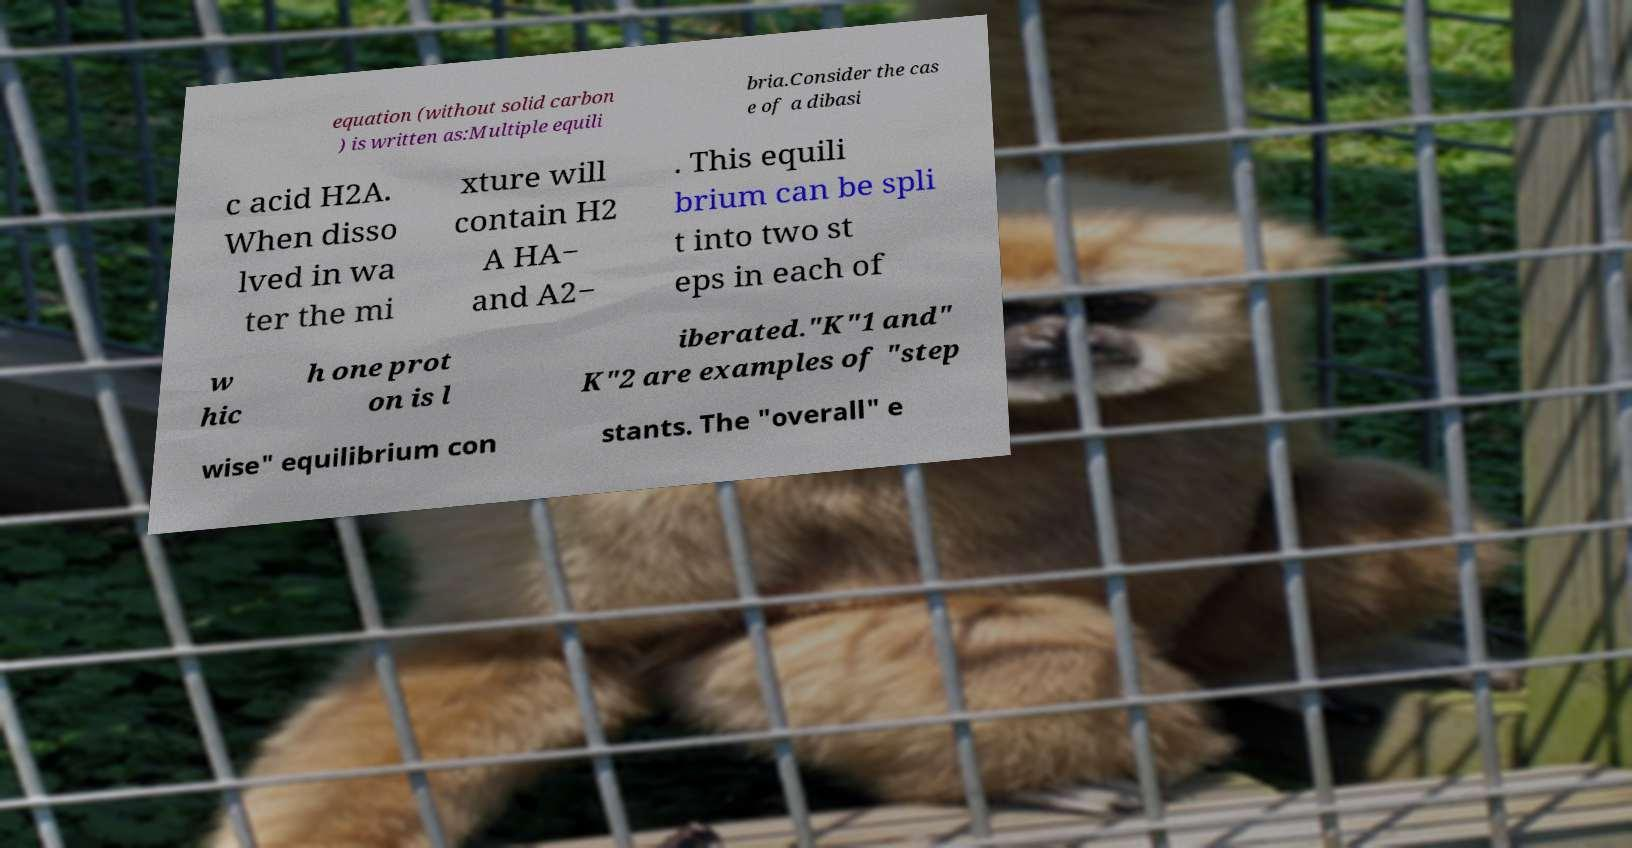There's text embedded in this image that I need extracted. Can you transcribe it verbatim? equation (without solid carbon ) is written as:Multiple equili bria.Consider the cas e of a dibasi c acid H2A. When disso lved in wa ter the mi xture will contain H2 A HA− and A2− . This equili brium can be spli t into two st eps in each of w hic h one prot on is l iberated."K"1 and" K"2 are examples of "step wise" equilibrium con stants. The "overall" e 